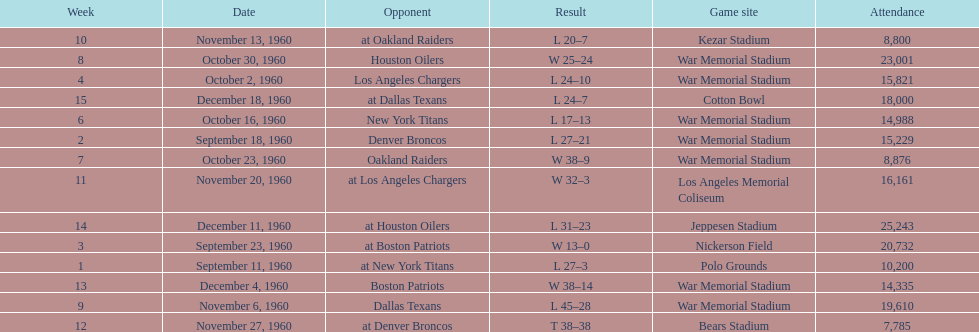The total number of games played at war memorial stadium was how many? 7. 